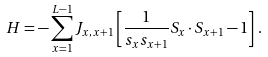Convert formula to latex. <formula><loc_0><loc_0><loc_500><loc_500>H = - \sum _ { x = 1 } ^ { L - 1 } J _ { x , x + 1 } \left [ \frac { 1 } { s _ { x } s _ { x + 1 } } S _ { x } \cdot S _ { x + 1 } - 1 \right ] \, .</formula> 